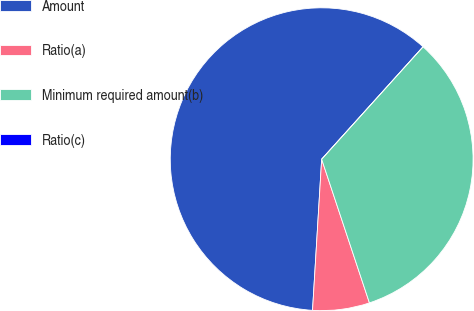Convert chart. <chart><loc_0><loc_0><loc_500><loc_500><pie_chart><fcel>Amount<fcel>Ratio(a)<fcel>Minimum required amount(b)<fcel>Ratio(c)<nl><fcel>60.72%<fcel>6.07%<fcel>33.21%<fcel>0.0%<nl></chart> 